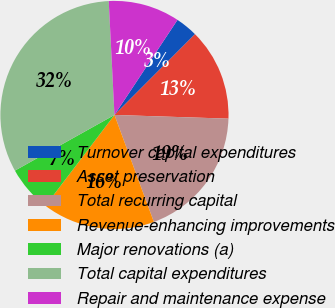<chart> <loc_0><loc_0><loc_500><loc_500><pie_chart><fcel>Turnover capital expenditures<fcel>Asset preservation<fcel>Total recurring capital<fcel>Revenue-enhancing improvements<fcel>Major renovations (a)<fcel>Total capital expenditures<fcel>Repair and maintenance expense<nl><fcel>3.16%<fcel>13.04%<fcel>18.87%<fcel>15.96%<fcel>6.54%<fcel>32.32%<fcel>10.12%<nl></chart> 